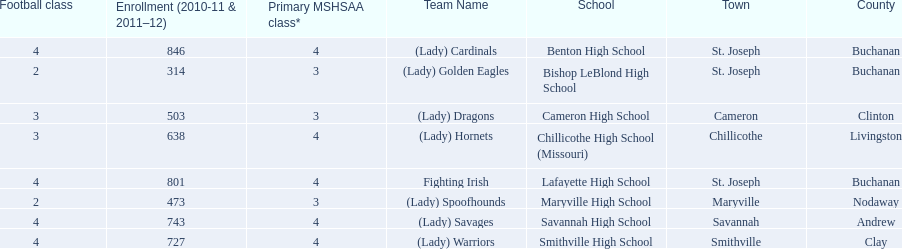What are the three schools in the town of st. joseph? St. Joseph, St. Joseph, St. Joseph. Of the three schools in st. joseph which school's team name does not depict a type of animal? Lafayette High School. 